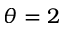<formula> <loc_0><loc_0><loc_500><loc_500>\theta = 2</formula> 